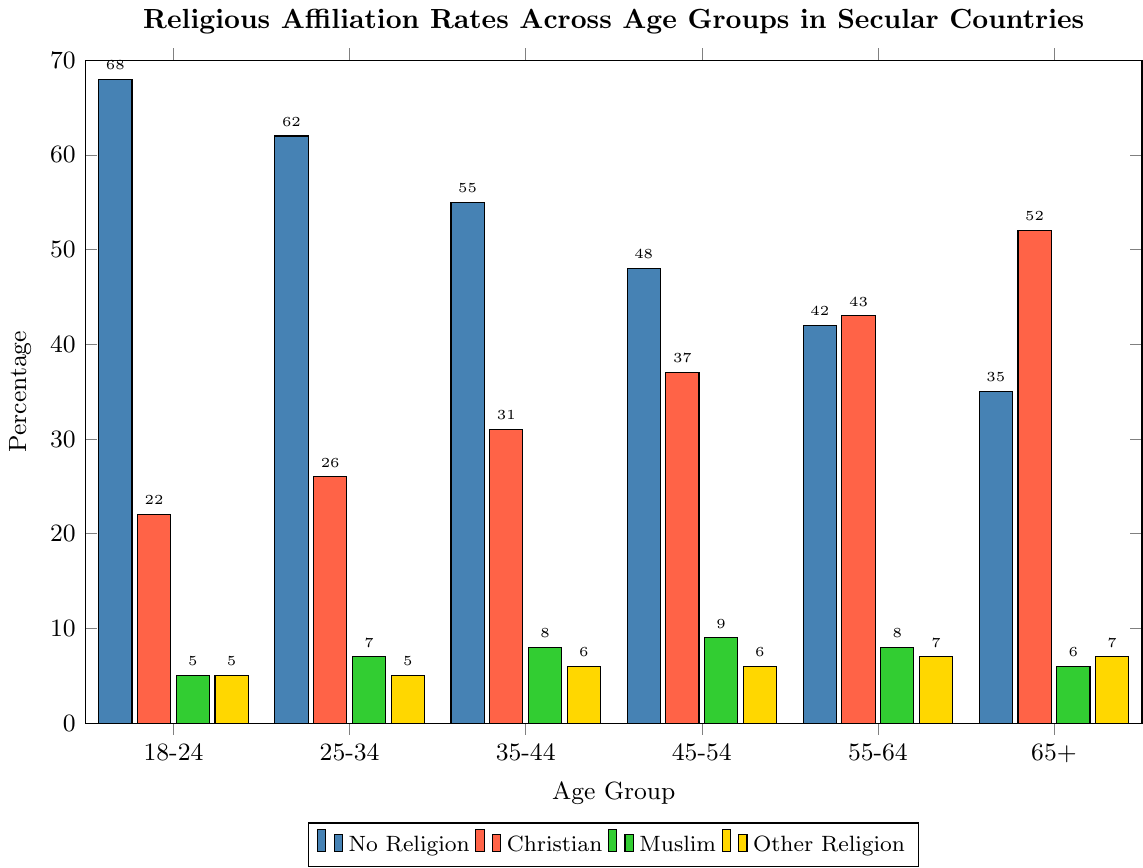What percentage of the 18-24 age group identifies as non-religious? Look for the bar corresponding to the 18-24 age group under "No Religion" category. The height of this bar represents 68%.
Answer: 68% Which age group has the highest percentage of Christians? Identify the bar with the highest height in the "Christian" category. The 65+ age group has the tallest bar, indicating 52%.
Answer: 65+ What's the total percentage of people identifying as Muslims in all age groups combined? Add up the percentages of Muslims across all age groups: 5 + 7 + 8 + 9 + 8 + 6 = 43%.
Answer: 43% Compare the difference in the percentage of the non-religious between the 18-24 and 65+ age groups. Look at the "No Religion" percentages for both age groups: 68% for 18-24 and 35% for 65+. The difference is 68 - 35 = 33%.
Answer: 33% Which age group has the smallest difference between those identifying as Christians and those identifying as non-religious? Calculate the difference for each age group: 18-24 (68-22=46), 25-34 (62-26=36), 35-44 (55-31=24), 45-54 (48-37=11), 55-64 (42-43=1), 65+ (35-52=-17). The 55-64 age group has the smallest difference of 1%.
Answer: 55-64 What is the average percentage of "Other Religion" affiliation across all age groups? Add the percentages for "Other Religion" across all age groups and divide by the number of age groups: (5 + 5 + 6 + 6 + 7 + 7) / 6 = 36 / 6 = 6%.
Answer: 6% By how much does the Muslim affiliation percentage in the 35-44 age group exceed that in the 18-24 age group? Find the percentages for Muslims in both age groups and subtract: 8% - 5% = 3%.
Answer: 3% How does the percentage of the "No Religion" category change from the 25-34 age group to the 45-54 age group? Look at the "No Religion" percentages for the 25-34 (62%) and 45-54 (48%) age groups, the difference is 62 - 48 = 14%.
Answer: It decreases by 14% 